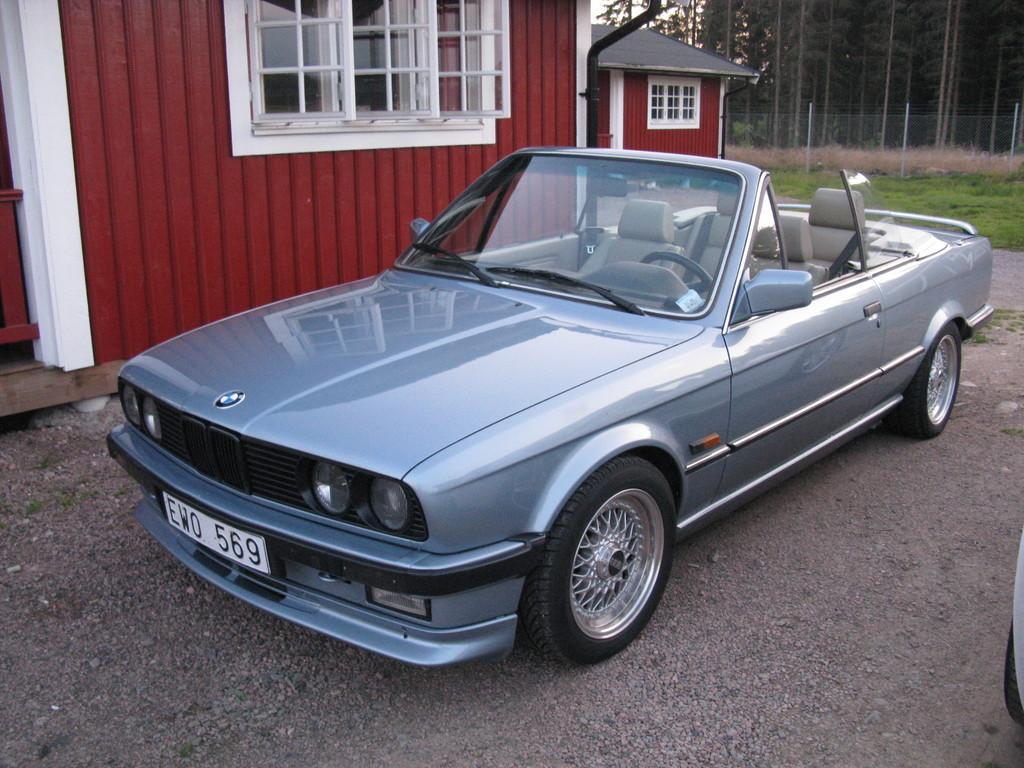Can you describe this image briefly? In the foreground of this image, there is a car on the ground. Behind it, there is a house. In the background, there is fencing, grass and trees. 